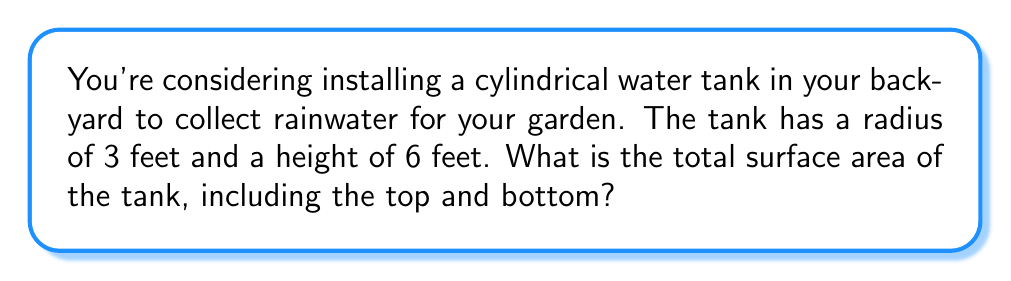Teach me how to tackle this problem. Let's approach this step-by-step:

1) The surface area of a cylinder consists of three parts:
   - The circular top
   - The circular bottom
   - The curved lateral surface

2) For the circular top and bottom:
   - Area of a circle = $\pi r^2$
   - Radius (r) = 3 feet
   - Area of one circular face = $\pi (3)^2 = 9\pi$ sq ft
   - Total area of top and bottom = $2(9\pi) = 18\pi$ sq ft

3) For the curved lateral surface:
   - Area of lateral surface = circumference × height
   - Circumference of the base = $2\pi r = 2\pi(3) = 6\pi$ ft
   - Height (h) = 6 feet
   - Lateral surface area = $6\pi \times 6 = 36\pi$ sq ft

4) Total surface area:
   - Sum of all parts = Area of top and bottom + Lateral surface area
   - Total surface area = $18\pi + 36\pi = 54\pi$ sq ft

Therefore, the total surface area of the cylindrical water tank is $54\pi$ square feet.
Answer: $54\pi$ sq ft 